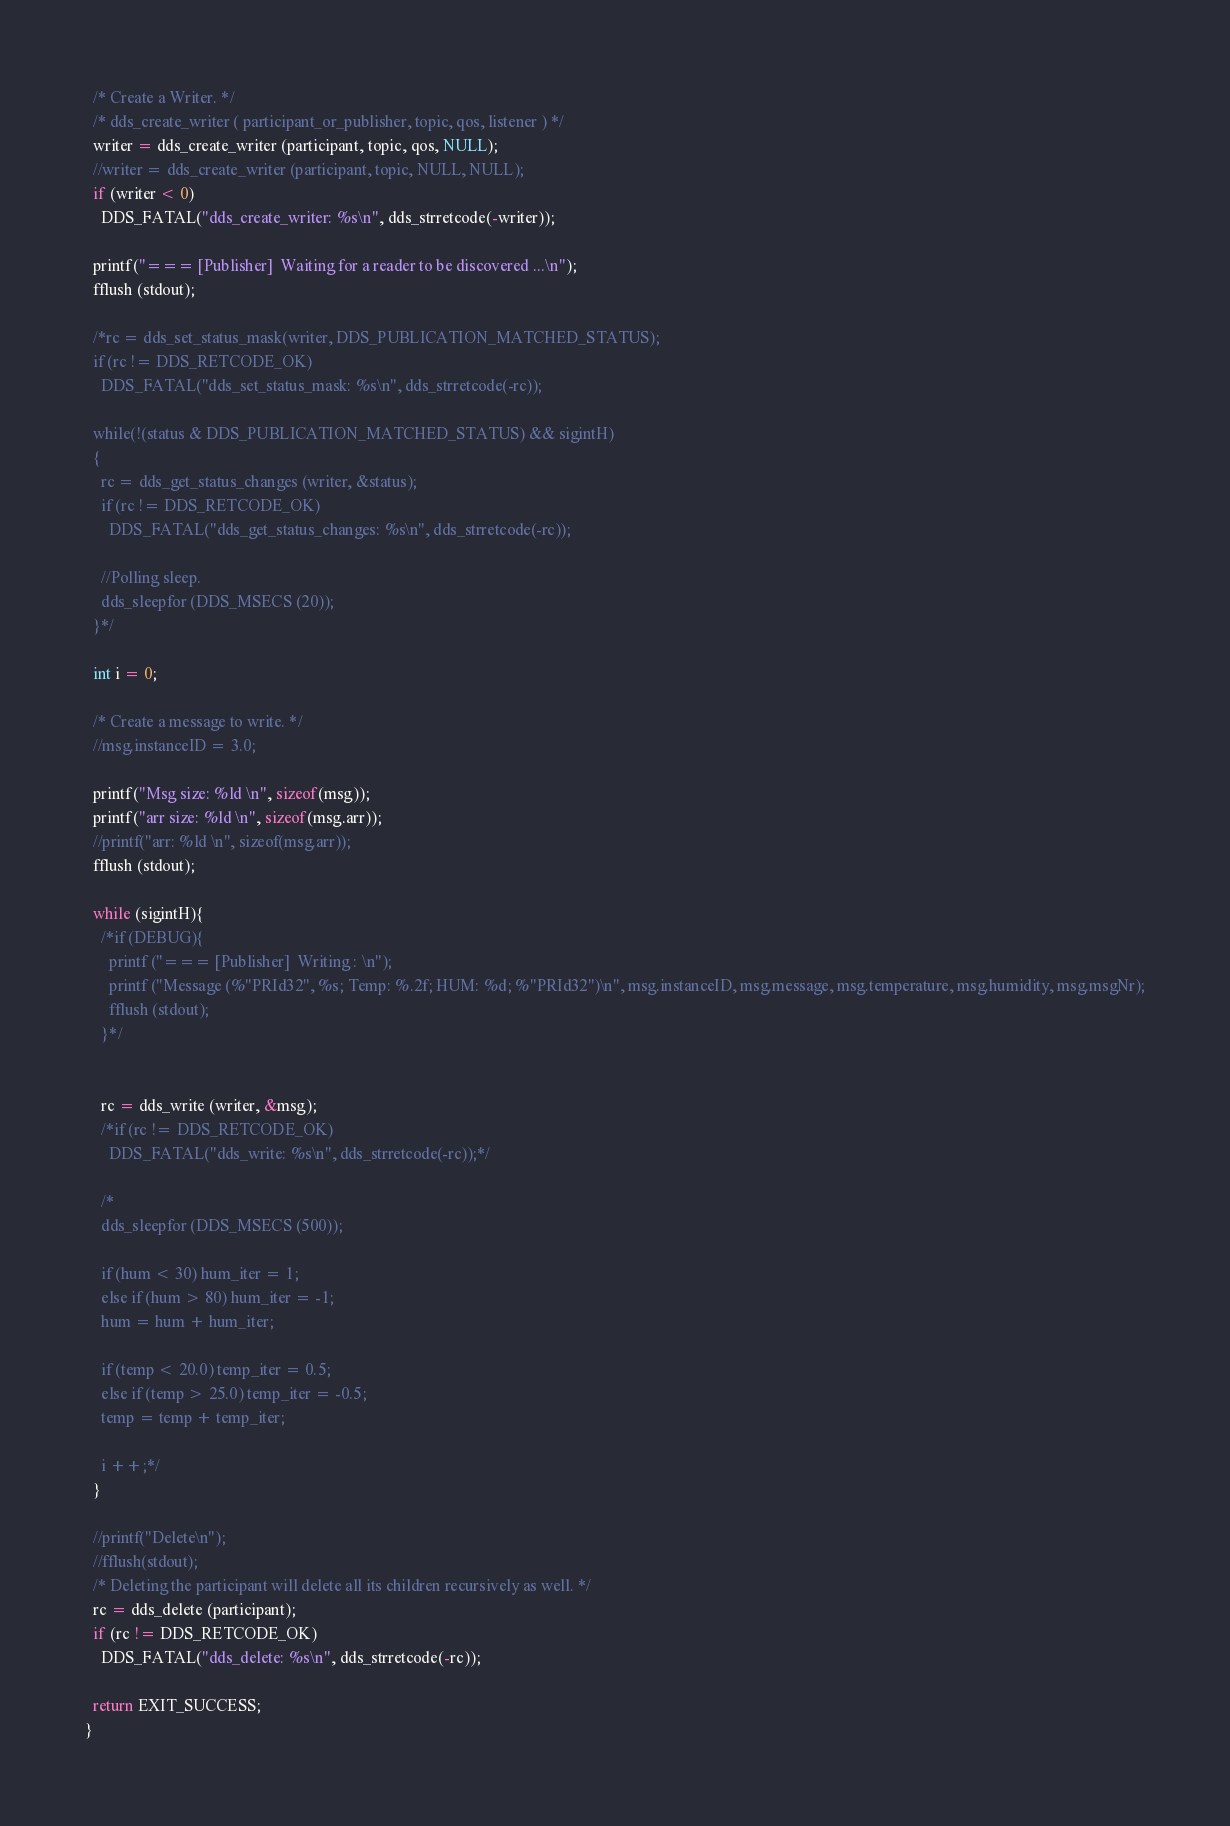Convert code to text. <code><loc_0><loc_0><loc_500><loc_500><_C_>  /* Create a Writer. */
  /* dds_create_writer ( participant_or_publisher, topic, qos, listener ) */
  writer = dds_create_writer (participant, topic, qos, NULL);
  //writer = dds_create_writer (participant, topic, NULL, NULL);
  if (writer < 0)
    DDS_FATAL("dds_create_writer: %s\n", dds_strretcode(-writer));

  printf("=== [Publisher]  Waiting for a reader to be discovered ...\n");
  fflush (stdout);

  /*rc = dds_set_status_mask(writer, DDS_PUBLICATION_MATCHED_STATUS);
  if (rc != DDS_RETCODE_OK)
    DDS_FATAL("dds_set_status_mask: %s\n", dds_strretcode(-rc));

  while(!(status & DDS_PUBLICATION_MATCHED_STATUS) && sigintH)
  {
    rc = dds_get_status_changes (writer, &status);
    if (rc != DDS_RETCODE_OK)
      DDS_FATAL("dds_get_status_changes: %s\n", dds_strretcode(-rc));

    //Polling sleep.
    dds_sleepfor (DDS_MSECS (20));
  }*/

  int i = 0;
  
  /* Create a message to write. */
  //msg.instanceID = 3.0;

  printf("Msg size: %ld \n", sizeof(msg));
  printf("arr size: %ld \n", sizeof(msg.arr));
  //printf("arr: %ld \n", sizeof(msg.arr));
  fflush (stdout);

  while (sigintH){
    /*if (DEBUG){
      printf ("=== [Publisher]  Writing : \n");
      printf ("Message (%"PRId32", %s; Temp: %.2f; HUM: %d; %"PRId32")\n", msg.instanceID, msg.message, msg.temperature, msg.humidity, msg.msgNr);
      fflush (stdout);
    }*/
    

    rc = dds_write (writer, &msg);
    /*if (rc != DDS_RETCODE_OK)
      DDS_FATAL("dds_write: %s\n", dds_strretcode(-rc));*/

  	/*
    dds_sleepfor (DDS_MSECS (500));
    
    if (hum < 30) hum_iter = 1;
    else if (hum > 80) hum_iter = -1;
    hum = hum + hum_iter;

    if (temp < 20.0) temp_iter = 0.5;
    else if (temp > 25.0) temp_iter = -0.5;
    temp = temp + temp_iter;

    i ++;*/
  }

  //printf("Delete\n");
  //fflush(stdout);
  /* Deleting the participant will delete all its children recursively as well. */
  rc = dds_delete (participant);
  if (rc != DDS_RETCODE_OK)
    DDS_FATAL("dds_delete: %s\n", dds_strretcode(-rc));

  return EXIT_SUCCESS;
}
</code> 